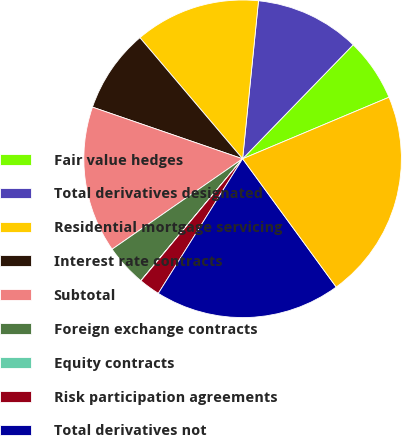<chart> <loc_0><loc_0><loc_500><loc_500><pie_chart><fcel>Fair value hedges<fcel>Total derivatives designated<fcel>Residential mortgage servicing<fcel>Interest rate contracts<fcel>Subtotal<fcel>Foreign exchange contracts<fcel>Equity contracts<fcel>Risk participation agreements<fcel>Total derivatives not<fcel>Total Gross Derivatives<nl><fcel>6.41%<fcel>10.66%<fcel>12.79%<fcel>8.53%<fcel>14.92%<fcel>4.28%<fcel>0.02%<fcel>2.15%<fcel>18.94%<fcel>21.3%<nl></chart> 